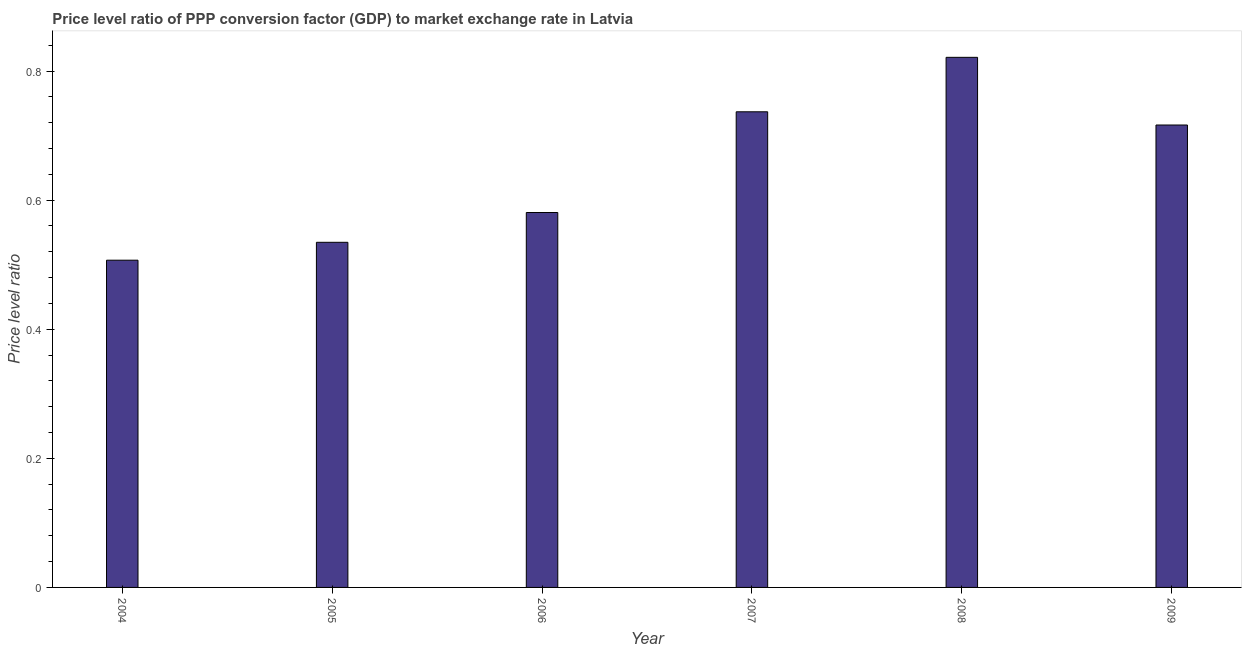Does the graph contain grids?
Offer a very short reply. No. What is the title of the graph?
Provide a short and direct response. Price level ratio of PPP conversion factor (GDP) to market exchange rate in Latvia. What is the label or title of the Y-axis?
Your answer should be very brief. Price level ratio. What is the price level ratio in 2005?
Offer a terse response. 0.53. Across all years, what is the maximum price level ratio?
Offer a very short reply. 0.82. Across all years, what is the minimum price level ratio?
Keep it short and to the point. 0.51. In which year was the price level ratio maximum?
Make the answer very short. 2008. In which year was the price level ratio minimum?
Offer a very short reply. 2004. What is the sum of the price level ratio?
Give a very brief answer. 3.9. What is the difference between the price level ratio in 2005 and 2007?
Keep it short and to the point. -0.2. What is the average price level ratio per year?
Your response must be concise. 0.65. What is the median price level ratio?
Your answer should be very brief. 0.65. What is the ratio of the price level ratio in 2008 to that in 2009?
Keep it short and to the point. 1.15. Is the price level ratio in 2008 less than that in 2009?
Provide a succinct answer. No. Is the difference between the price level ratio in 2005 and 2007 greater than the difference between any two years?
Give a very brief answer. No. What is the difference between the highest and the second highest price level ratio?
Keep it short and to the point. 0.08. What is the difference between the highest and the lowest price level ratio?
Your answer should be compact. 0.31. In how many years, is the price level ratio greater than the average price level ratio taken over all years?
Make the answer very short. 3. Are all the bars in the graph horizontal?
Provide a short and direct response. No. How many years are there in the graph?
Make the answer very short. 6. What is the Price level ratio in 2004?
Your answer should be compact. 0.51. What is the Price level ratio of 2005?
Give a very brief answer. 0.53. What is the Price level ratio in 2006?
Provide a succinct answer. 0.58. What is the Price level ratio in 2007?
Your answer should be compact. 0.74. What is the Price level ratio of 2008?
Keep it short and to the point. 0.82. What is the Price level ratio of 2009?
Your response must be concise. 0.72. What is the difference between the Price level ratio in 2004 and 2005?
Provide a short and direct response. -0.03. What is the difference between the Price level ratio in 2004 and 2006?
Make the answer very short. -0.07. What is the difference between the Price level ratio in 2004 and 2007?
Make the answer very short. -0.23. What is the difference between the Price level ratio in 2004 and 2008?
Keep it short and to the point. -0.31. What is the difference between the Price level ratio in 2004 and 2009?
Your answer should be very brief. -0.21. What is the difference between the Price level ratio in 2005 and 2006?
Your answer should be compact. -0.05. What is the difference between the Price level ratio in 2005 and 2007?
Your answer should be compact. -0.2. What is the difference between the Price level ratio in 2005 and 2008?
Your response must be concise. -0.29. What is the difference between the Price level ratio in 2005 and 2009?
Provide a short and direct response. -0.18. What is the difference between the Price level ratio in 2006 and 2007?
Give a very brief answer. -0.16. What is the difference between the Price level ratio in 2006 and 2008?
Ensure brevity in your answer.  -0.24. What is the difference between the Price level ratio in 2006 and 2009?
Make the answer very short. -0.14. What is the difference between the Price level ratio in 2007 and 2008?
Your answer should be very brief. -0.08. What is the difference between the Price level ratio in 2007 and 2009?
Make the answer very short. 0.02. What is the difference between the Price level ratio in 2008 and 2009?
Provide a short and direct response. 0.1. What is the ratio of the Price level ratio in 2004 to that in 2005?
Keep it short and to the point. 0.95. What is the ratio of the Price level ratio in 2004 to that in 2006?
Keep it short and to the point. 0.87. What is the ratio of the Price level ratio in 2004 to that in 2007?
Offer a terse response. 0.69. What is the ratio of the Price level ratio in 2004 to that in 2008?
Provide a short and direct response. 0.62. What is the ratio of the Price level ratio in 2004 to that in 2009?
Offer a terse response. 0.71. What is the ratio of the Price level ratio in 2005 to that in 2006?
Your answer should be compact. 0.92. What is the ratio of the Price level ratio in 2005 to that in 2007?
Your answer should be compact. 0.73. What is the ratio of the Price level ratio in 2005 to that in 2008?
Keep it short and to the point. 0.65. What is the ratio of the Price level ratio in 2005 to that in 2009?
Offer a very short reply. 0.75. What is the ratio of the Price level ratio in 2006 to that in 2007?
Keep it short and to the point. 0.79. What is the ratio of the Price level ratio in 2006 to that in 2008?
Ensure brevity in your answer.  0.71. What is the ratio of the Price level ratio in 2006 to that in 2009?
Your answer should be compact. 0.81. What is the ratio of the Price level ratio in 2007 to that in 2008?
Your response must be concise. 0.9. What is the ratio of the Price level ratio in 2007 to that in 2009?
Offer a very short reply. 1.03. What is the ratio of the Price level ratio in 2008 to that in 2009?
Your answer should be very brief. 1.15. 